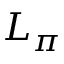<formula> <loc_0><loc_0><loc_500><loc_500>L _ { \pi }</formula> 